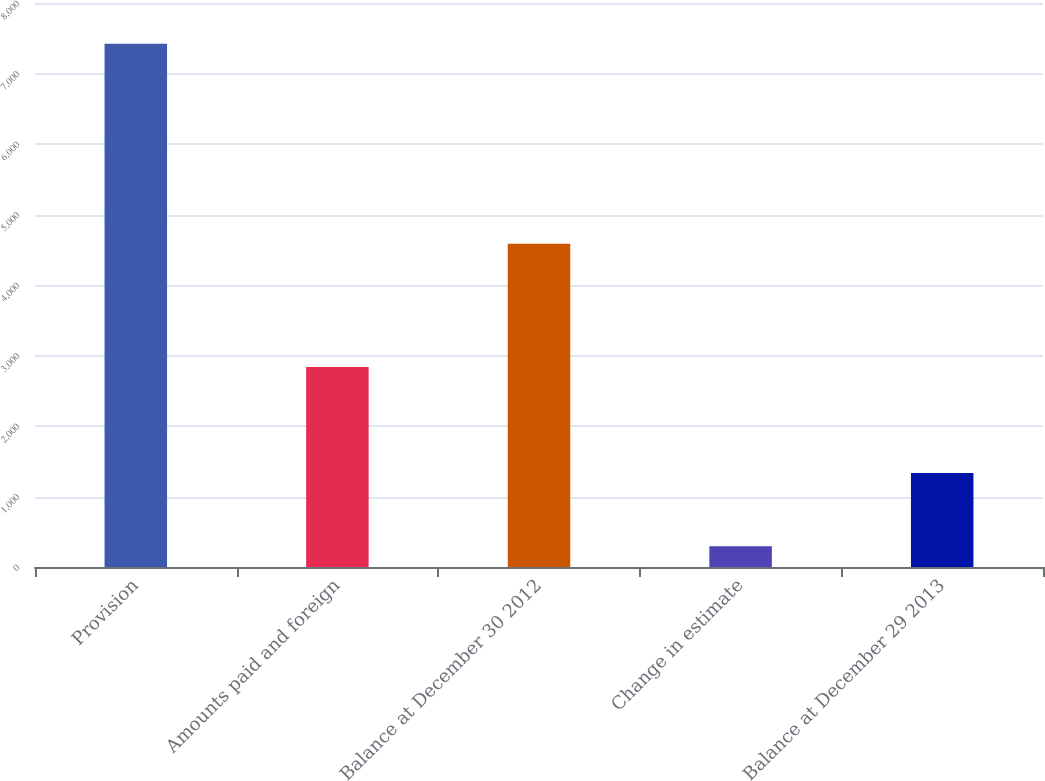Convert chart. <chart><loc_0><loc_0><loc_500><loc_500><bar_chart><fcel>Provision<fcel>Amounts paid and foreign<fcel>Balance at December 30 2012<fcel>Change in estimate<fcel>Balance at December 29 2013<nl><fcel>7422<fcel>2836<fcel>4586<fcel>294<fcel>1335<nl></chart> 